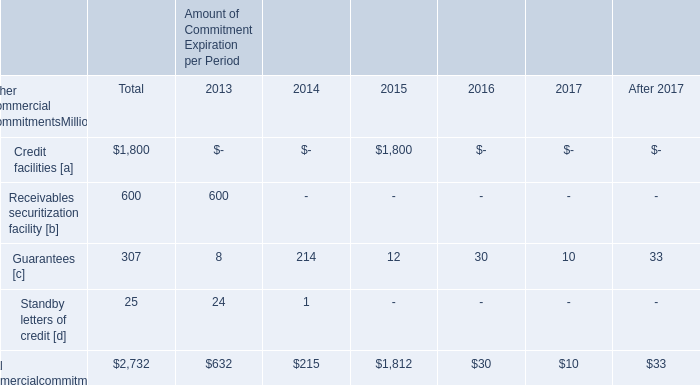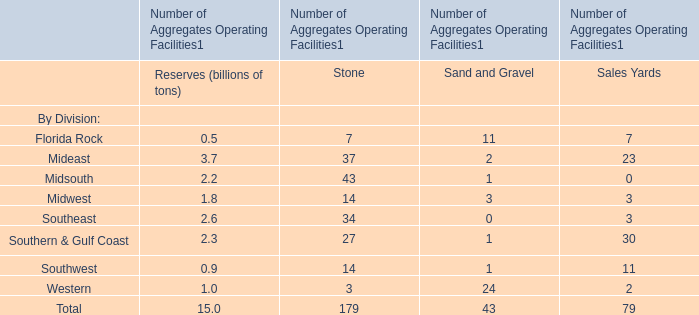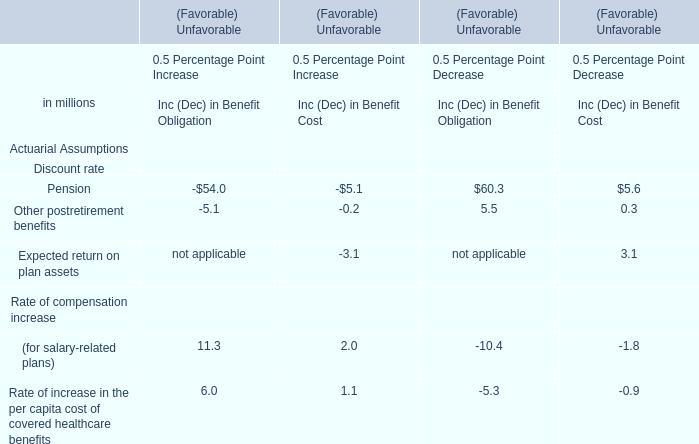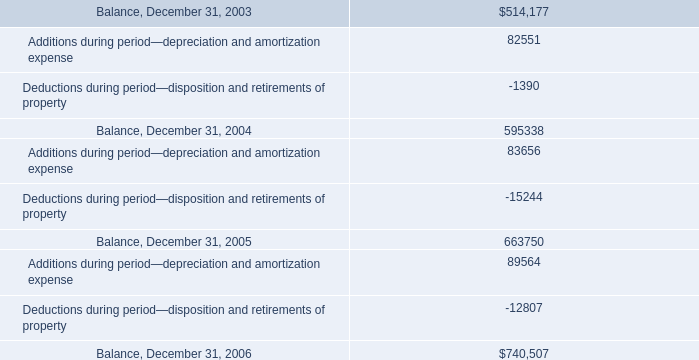what was the percentual increase in the additions during 2004 and 2005? 
Computations: ((83656 / 82551) - 1)
Answer: 0.01339. 